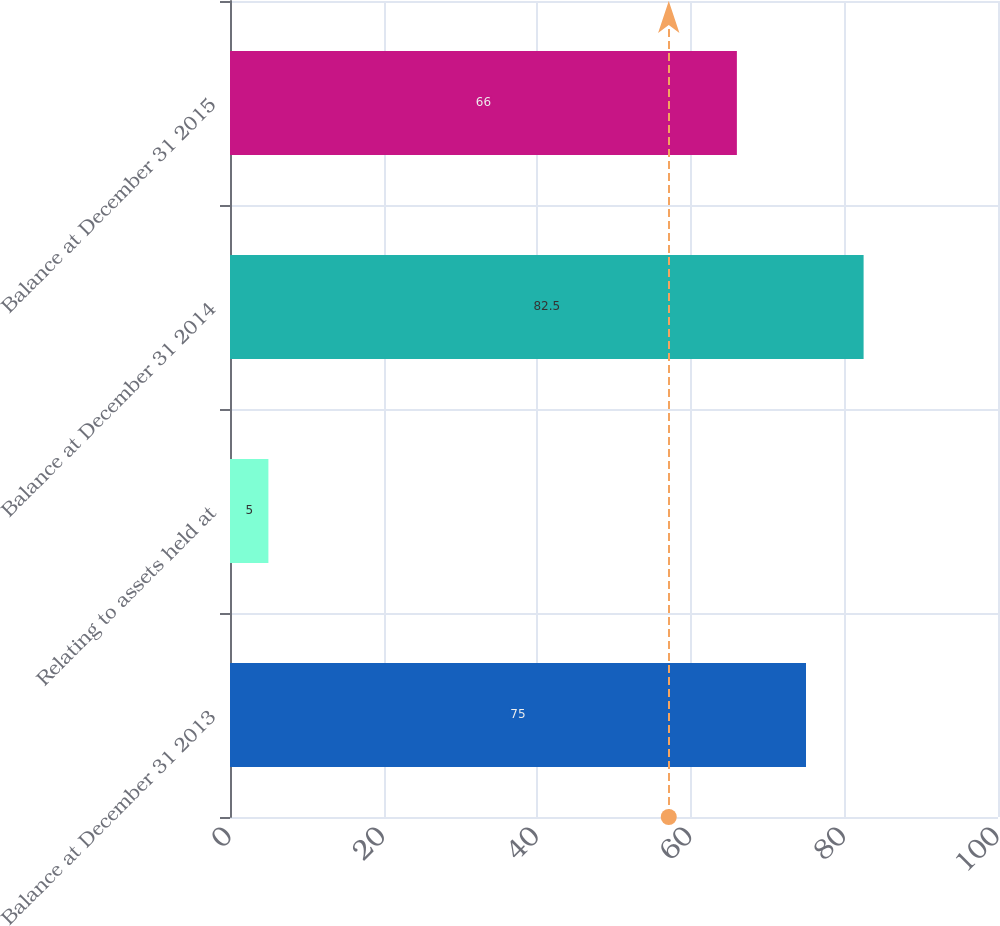<chart> <loc_0><loc_0><loc_500><loc_500><bar_chart><fcel>Balance at December 31 2013<fcel>Relating to assets held at<fcel>Balance at December 31 2014<fcel>Balance at December 31 2015<nl><fcel>75<fcel>5<fcel>82.5<fcel>66<nl></chart> 